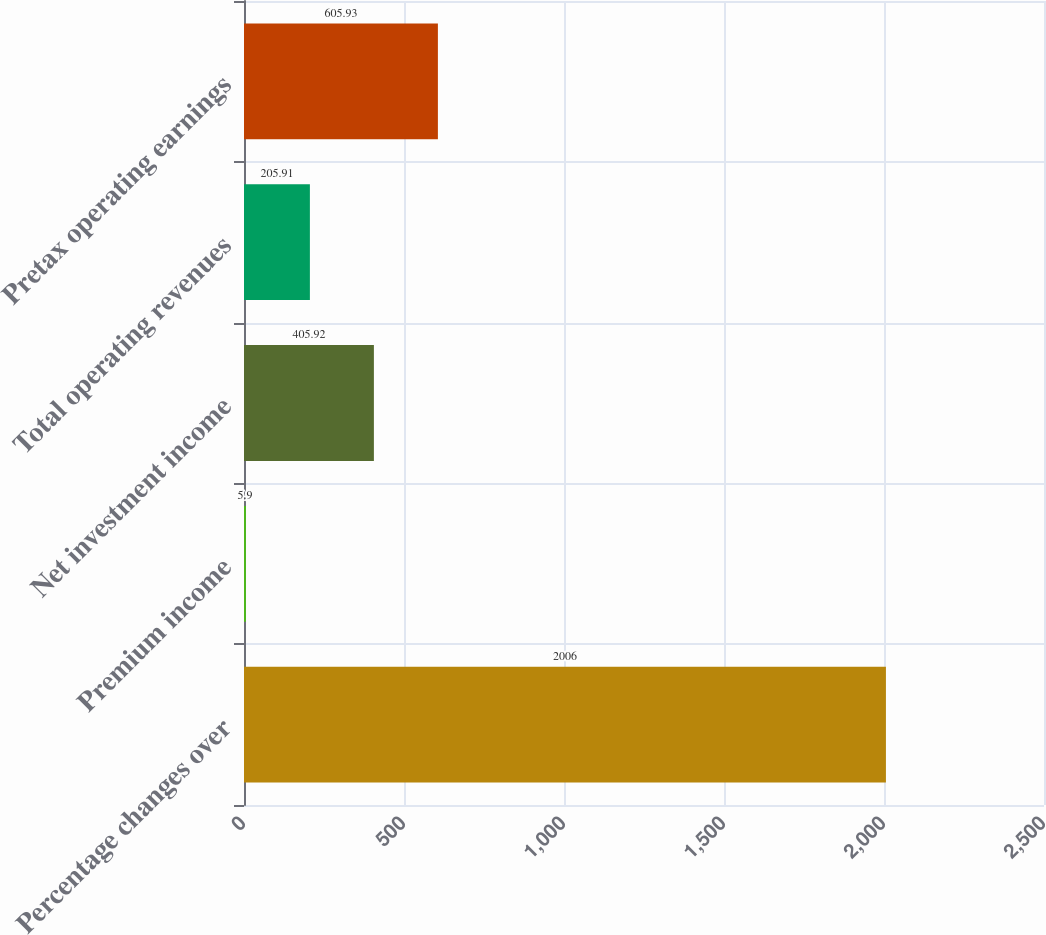Convert chart. <chart><loc_0><loc_0><loc_500><loc_500><bar_chart><fcel>Percentage changes over<fcel>Premium income<fcel>Net investment income<fcel>Total operating revenues<fcel>Pretax operating earnings<nl><fcel>2006<fcel>5.9<fcel>405.92<fcel>205.91<fcel>605.93<nl></chart> 